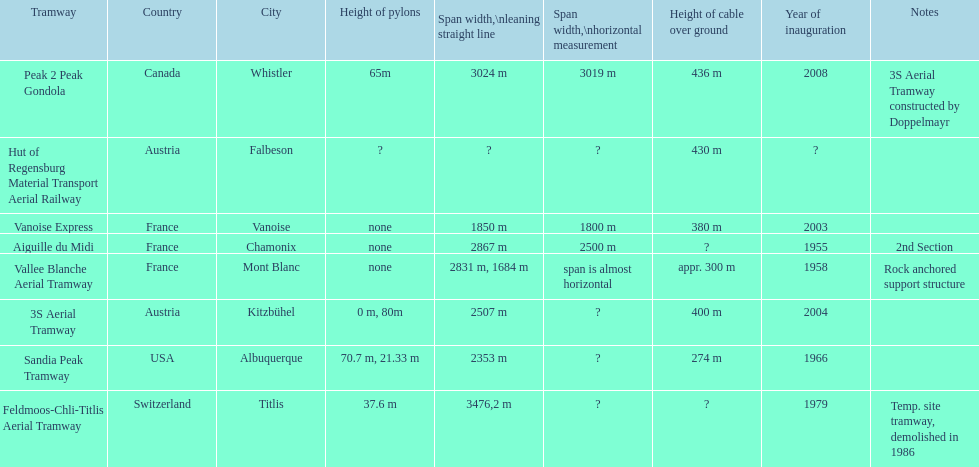Which tramway was built directly before the 3s aeriral tramway? Vanoise Express. 